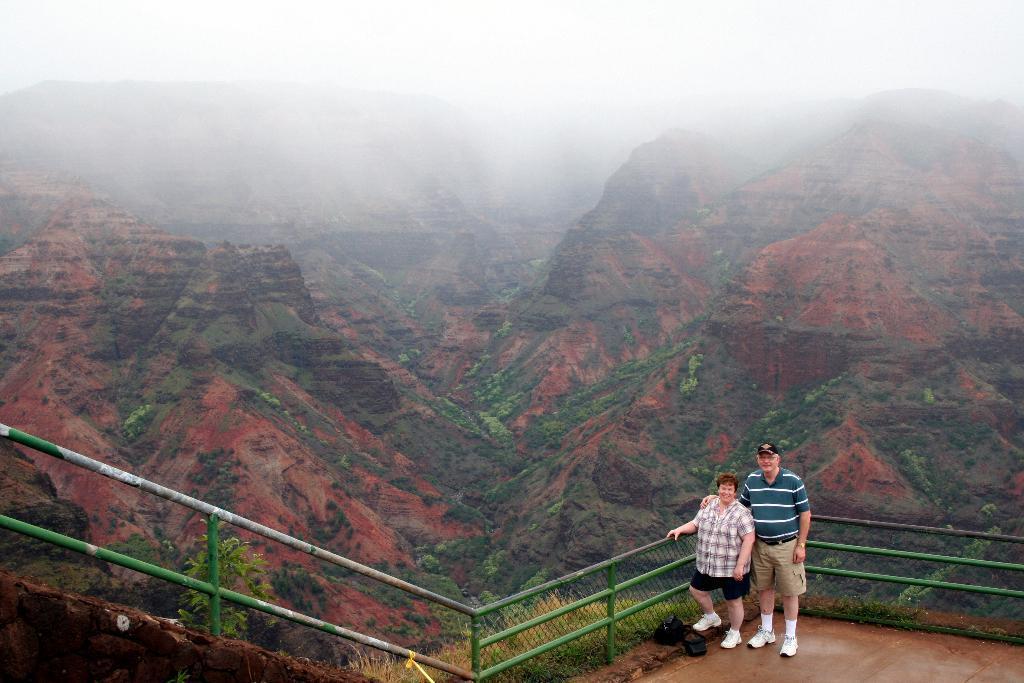In one or two sentences, can you explain what this image depicts? In this image there are two persons standing, there are iron rods , net , trees, hills, and in the background there is sky. 